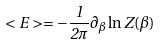Convert formula to latex. <formula><loc_0><loc_0><loc_500><loc_500>< E > = - \frac { 1 } { 2 \pi } \partial _ { \beta } \ln Z ( \beta )</formula> 